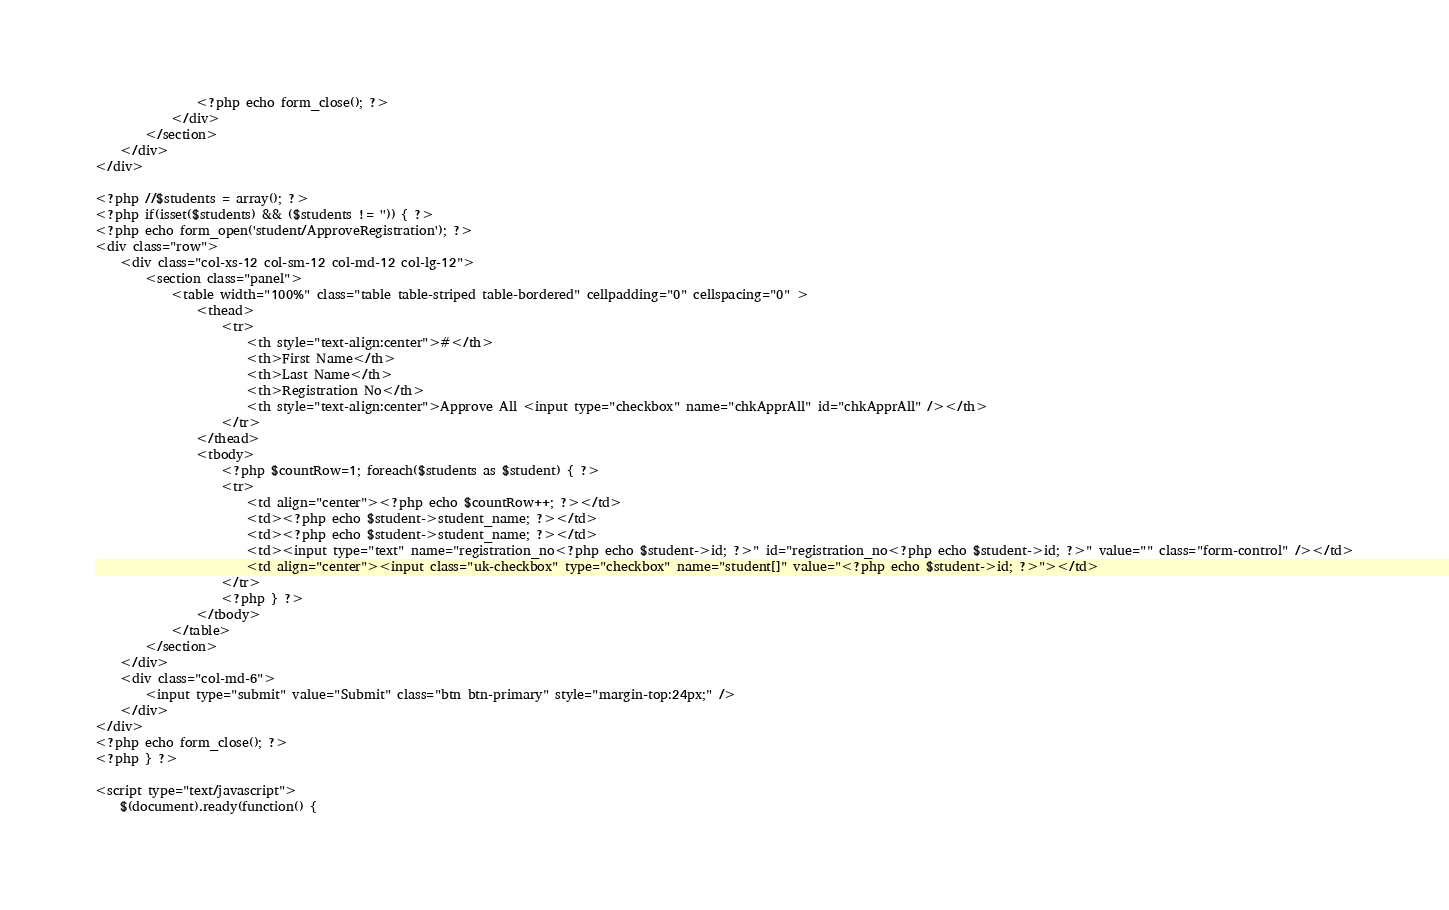Convert code to text. <code><loc_0><loc_0><loc_500><loc_500><_PHP_>				<?php echo form_close(); ?>
			</div>
		</section>
	</div>
</div>

<?php //$students = array(); ?>
<?php if(isset($students) && ($students != '')) { ?>
<?php echo form_open('student/ApproveRegistration'); ?>
<div class="row">
	<div class="col-xs-12 col-sm-12 col-md-12 col-lg-12">
		<section class="panel">
			<table width="100%" class="table table-striped table-bordered" cellpadding="0" cellspacing="0" >
				<thead>
					<tr>
						<th style="text-align:center">#</th>
						<th>First Name</th>
						<th>Last Name</th>
						<th>Registration No</th>
						<th style="text-align:center">Approve All <input type="checkbox" name="chkApprAll" id="chkApprAll" /></th>
					</tr>
				</thead>
				<tbody>
					<?php $countRow=1; foreach($students as $student) { ?>
					<tr>
						<td align="center"><?php echo $countRow++; ?></td>
						<td><?php echo $student->student_name; ?></td>
						<td><?php echo $student->student_name; ?></td>
						<td><input type="text" name="registration_no<?php echo $student->id; ?>" id="registration_no<?php echo $student->id; ?>" value="" class="form-control" /></td>
						<td align="center"><input class="uk-checkbox" type="checkbox" name="student[]" value="<?php echo $student->id; ?>"></td>
					</tr>
					<?php } ?>
				</tbody>
			</table>
		</section>
	</div>
	<div class="col-md-6">
		<input type="submit" value="Submit" class="btn btn-primary" style="margin-top:24px;" />
	</div>
</div>
<?php echo form_close(); ?>
<?php } ?>

<script type="text/javascript">
	$(document).ready(function() {</code> 